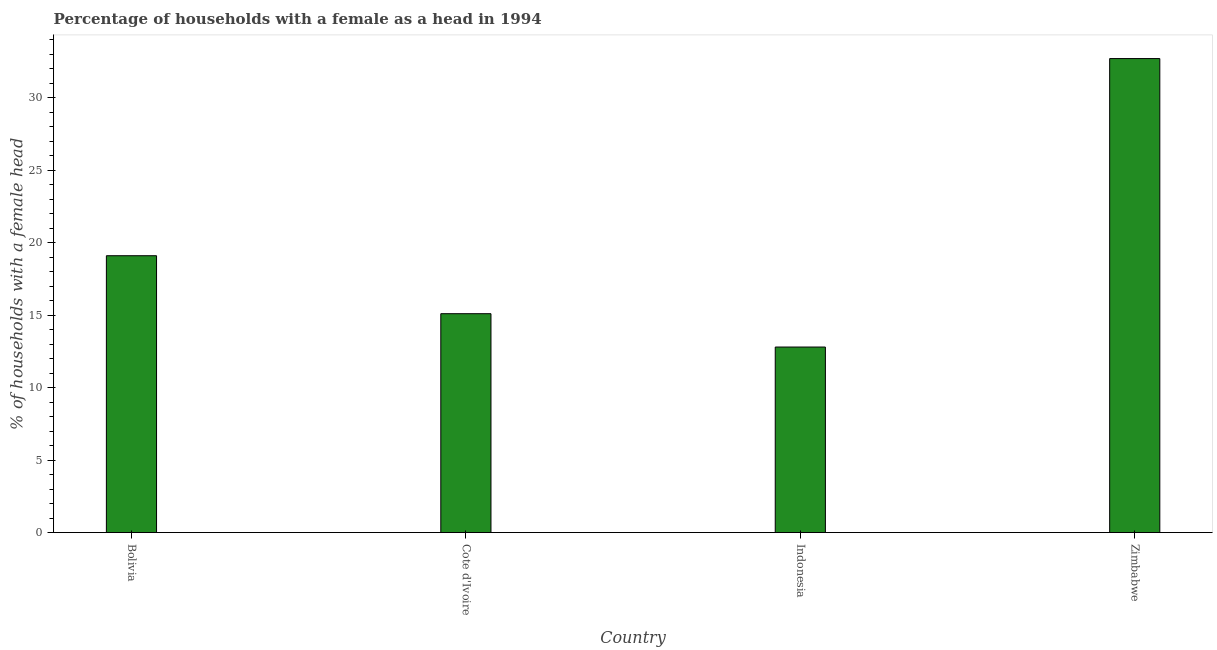What is the title of the graph?
Offer a terse response. Percentage of households with a female as a head in 1994. What is the label or title of the X-axis?
Your answer should be very brief. Country. What is the label or title of the Y-axis?
Keep it short and to the point. % of households with a female head. Across all countries, what is the maximum number of female supervised households?
Make the answer very short. 32.7. Across all countries, what is the minimum number of female supervised households?
Offer a very short reply. 12.8. In which country was the number of female supervised households maximum?
Your answer should be compact. Zimbabwe. What is the sum of the number of female supervised households?
Offer a terse response. 79.7. What is the average number of female supervised households per country?
Provide a short and direct response. 19.93. What is the median number of female supervised households?
Make the answer very short. 17.1. What is the ratio of the number of female supervised households in Bolivia to that in Zimbabwe?
Your response must be concise. 0.58. What is the difference between the highest and the second highest number of female supervised households?
Ensure brevity in your answer.  13.6. Is the sum of the number of female supervised households in Indonesia and Zimbabwe greater than the maximum number of female supervised households across all countries?
Provide a short and direct response. Yes. In how many countries, is the number of female supervised households greater than the average number of female supervised households taken over all countries?
Give a very brief answer. 1. Are all the bars in the graph horizontal?
Offer a terse response. No. How many countries are there in the graph?
Provide a succinct answer. 4. What is the % of households with a female head of Zimbabwe?
Make the answer very short. 32.7. What is the difference between the % of households with a female head in Cote d'Ivoire and Zimbabwe?
Ensure brevity in your answer.  -17.6. What is the difference between the % of households with a female head in Indonesia and Zimbabwe?
Make the answer very short. -19.9. What is the ratio of the % of households with a female head in Bolivia to that in Cote d'Ivoire?
Ensure brevity in your answer.  1.26. What is the ratio of the % of households with a female head in Bolivia to that in Indonesia?
Your answer should be very brief. 1.49. What is the ratio of the % of households with a female head in Bolivia to that in Zimbabwe?
Keep it short and to the point. 0.58. What is the ratio of the % of households with a female head in Cote d'Ivoire to that in Indonesia?
Your answer should be very brief. 1.18. What is the ratio of the % of households with a female head in Cote d'Ivoire to that in Zimbabwe?
Your response must be concise. 0.46. What is the ratio of the % of households with a female head in Indonesia to that in Zimbabwe?
Provide a short and direct response. 0.39. 